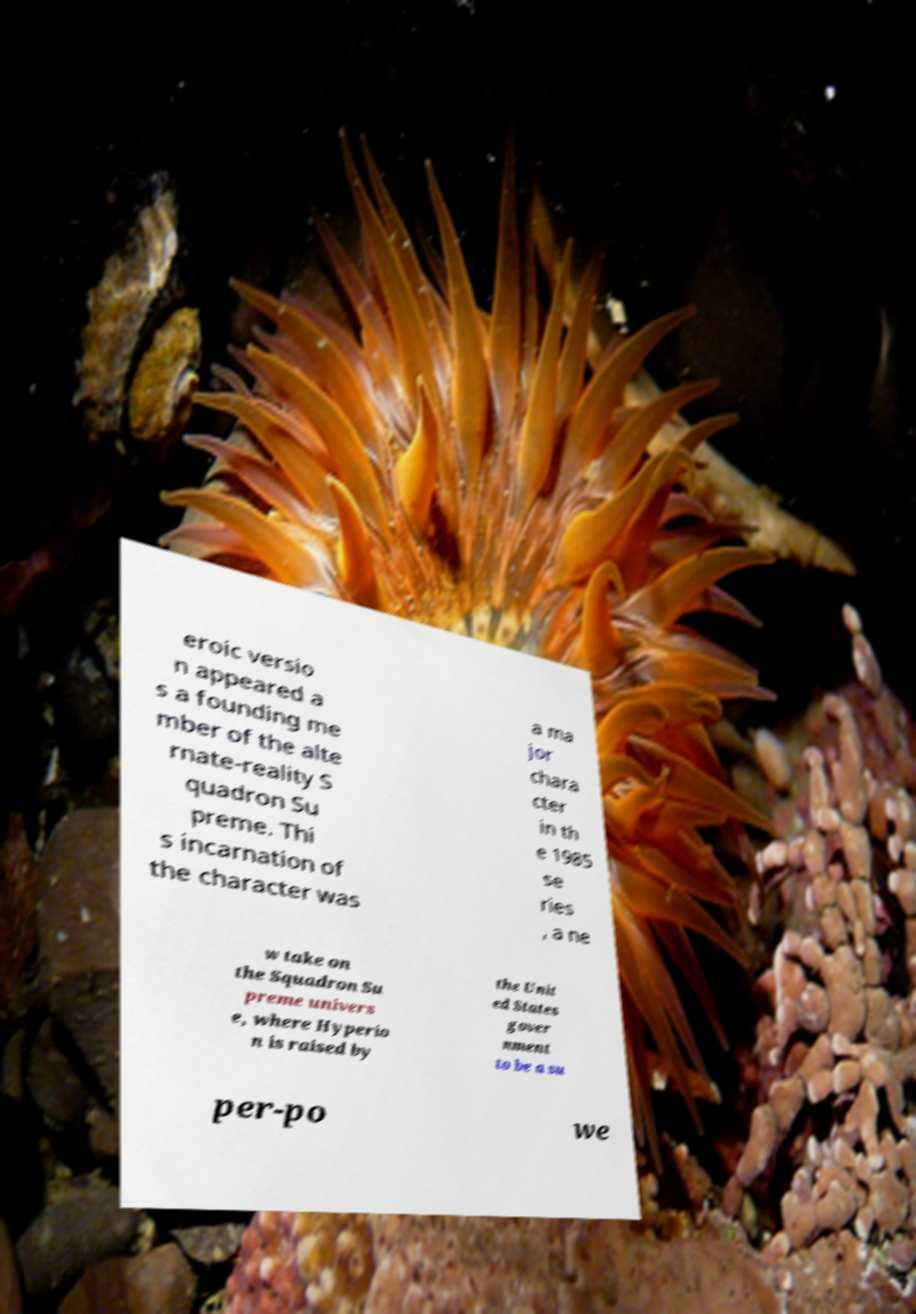For documentation purposes, I need the text within this image transcribed. Could you provide that? eroic versio n appeared a s a founding me mber of the alte rnate-reality S quadron Su preme. Thi s incarnation of the character was a ma jor chara cter in th e 1985 se ries , a ne w take on the Squadron Su preme univers e, where Hyperio n is raised by the Unit ed States gover nment to be a su per-po we 